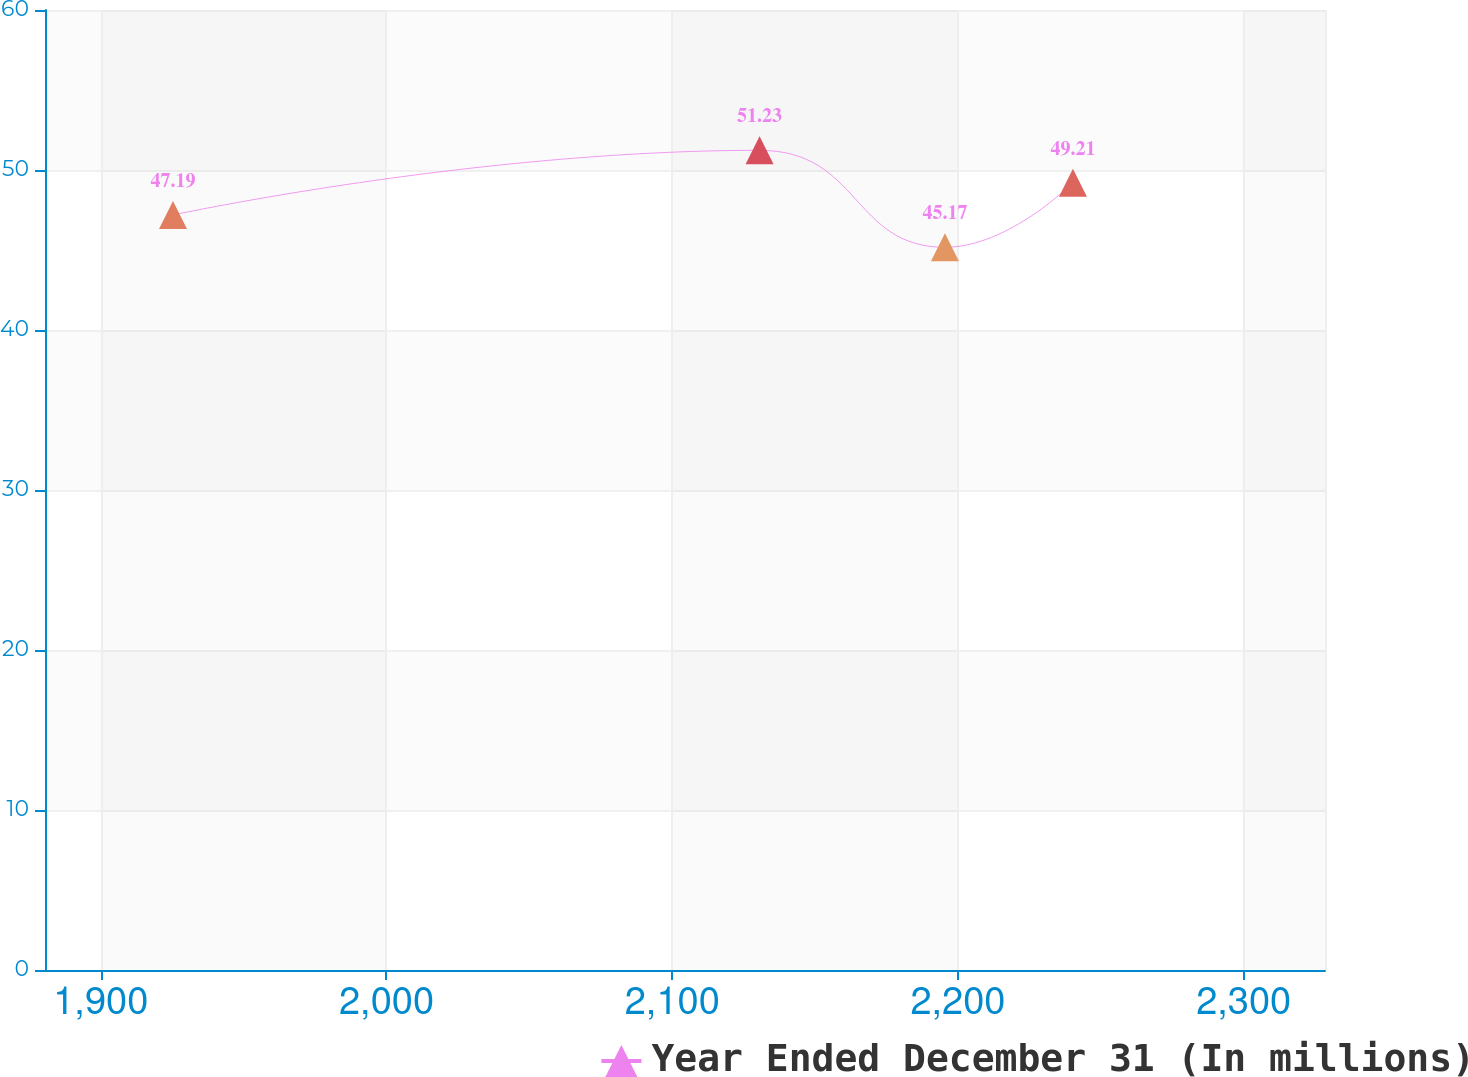<chart> <loc_0><loc_0><loc_500><loc_500><line_chart><ecel><fcel>Year Ended December 31 (In millions)<nl><fcel>1925.28<fcel>47.19<nl><fcel>2130.56<fcel>51.23<nl><fcel>2195.45<fcel>45.17<nl><fcel>2240.25<fcel>49.21<nl><fcel>2373.26<fcel>30.83<nl></chart> 